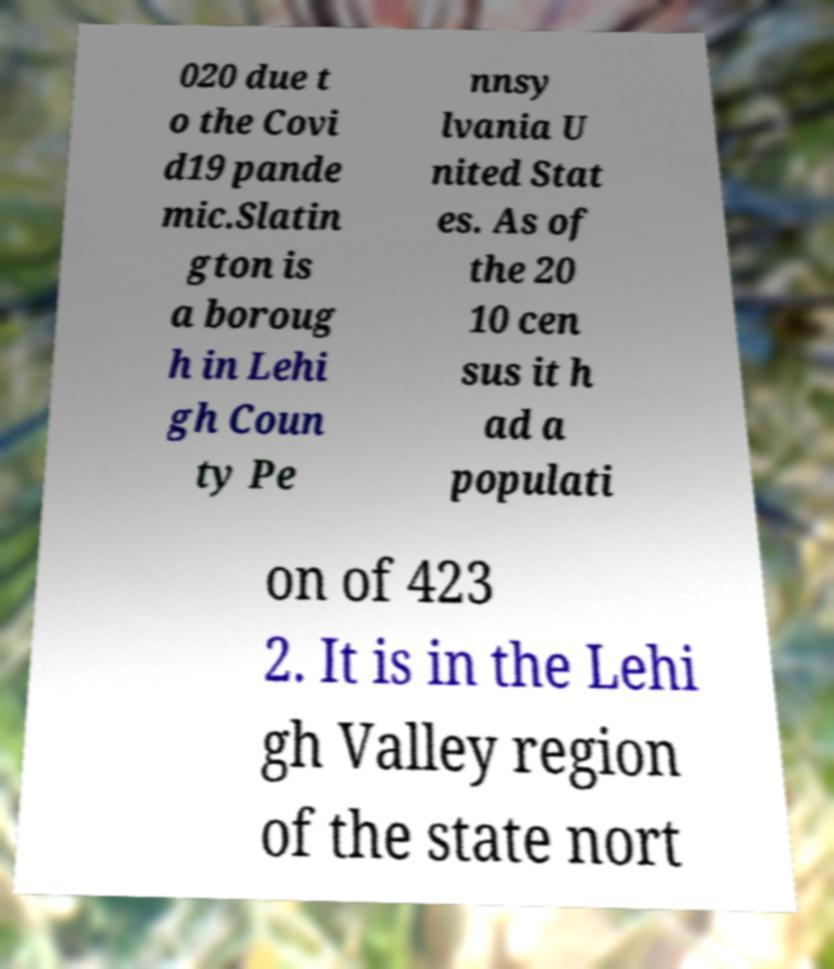There's text embedded in this image that I need extracted. Can you transcribe it verbatim? 020 due t o the Covi d19 pande mic.Slatin gton is a boroug h in Lehi gh Coun ty Pe nnsy lvania U nited Stat es. As of the 20 10 cen sus it h ad a populati on of 423 2. It is in the Lehi gh Valley region of the state nort 